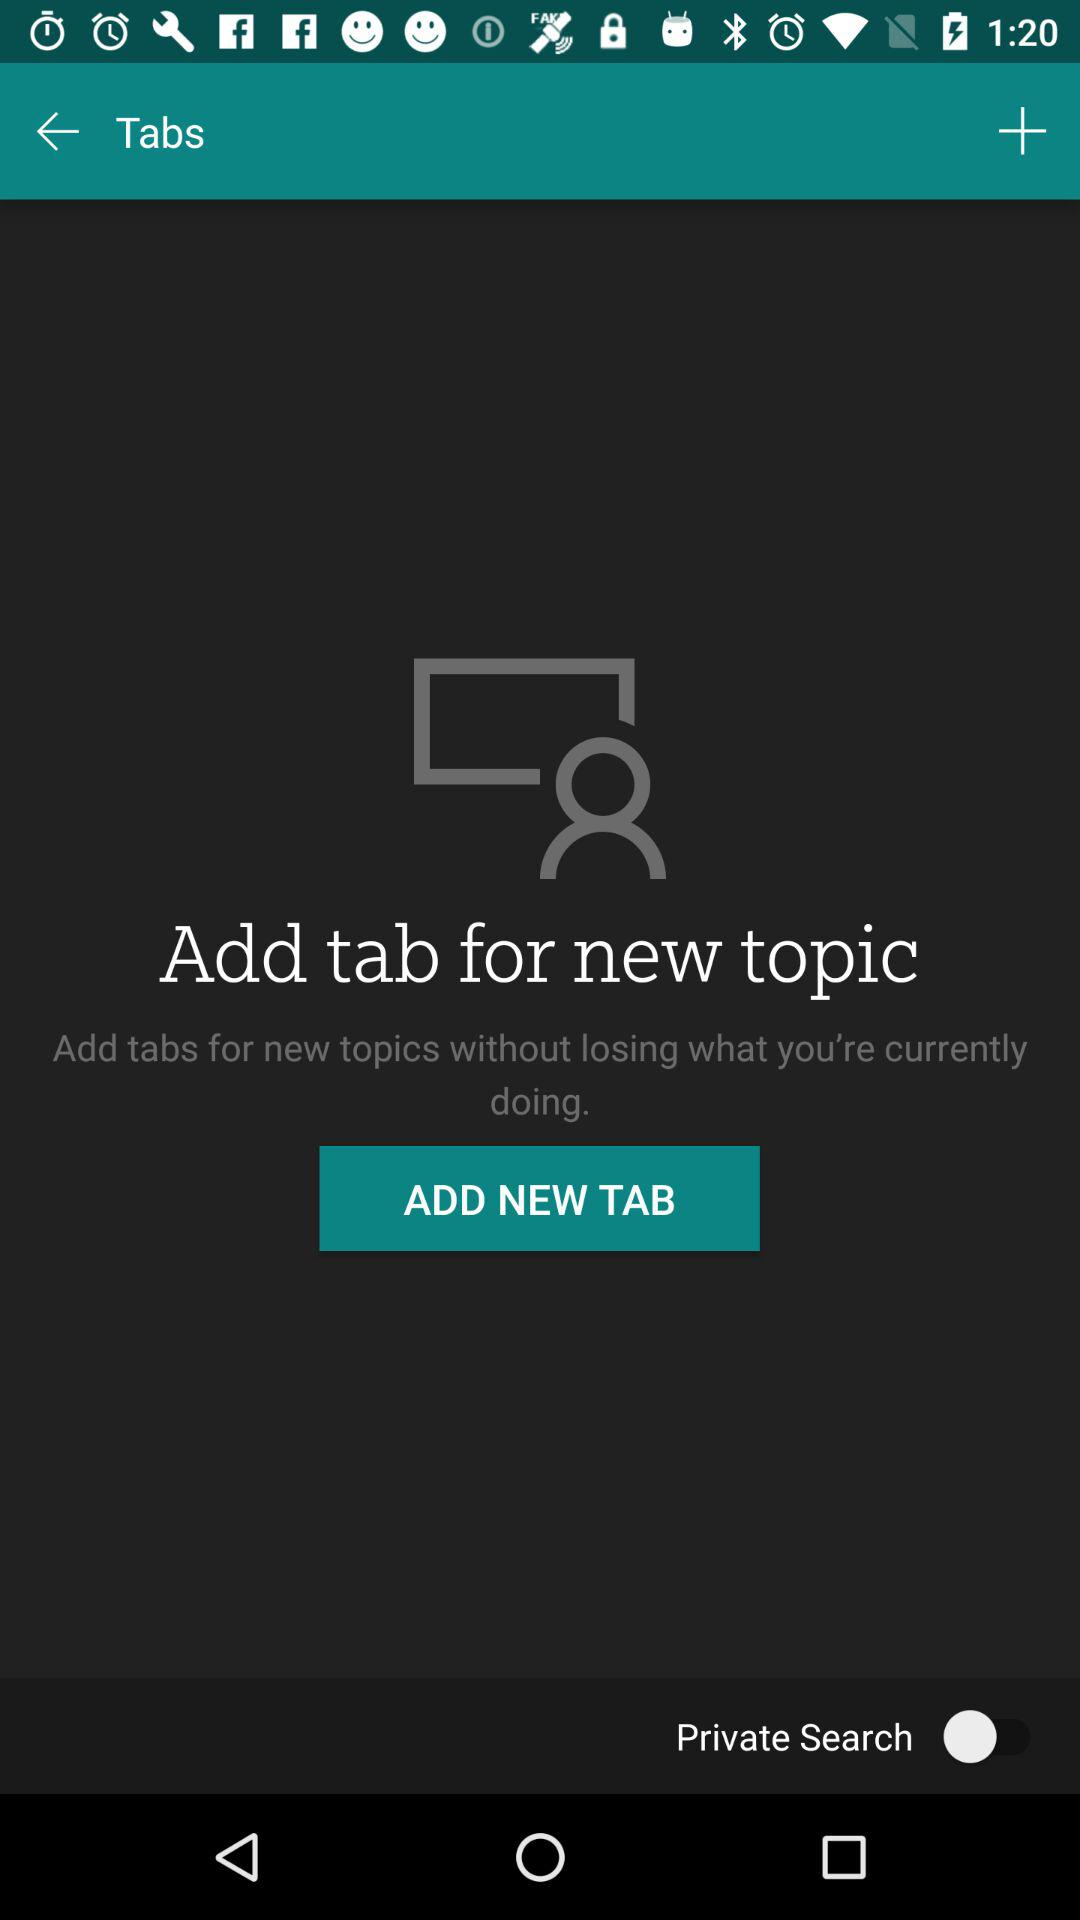Is "Private Search" enabled or disabled? "Private Search" is disabled. 